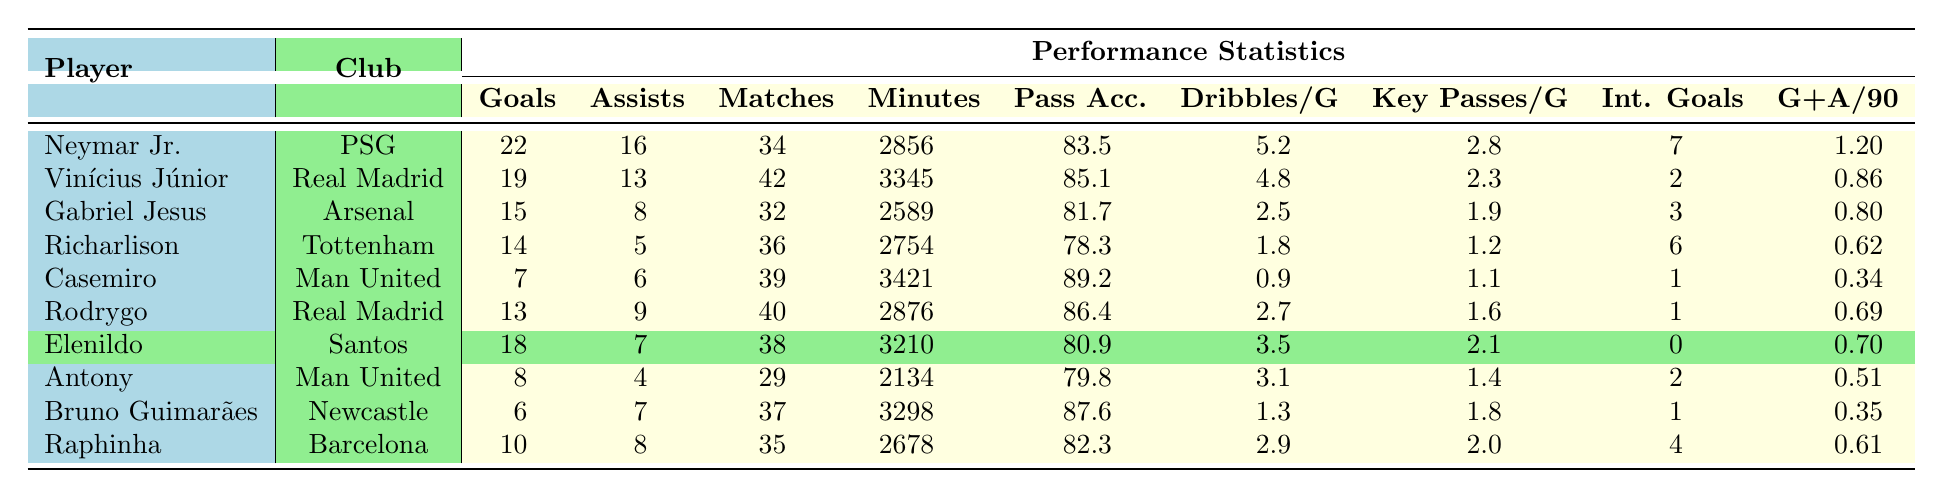What is the total number of goals scored by Neymar Jr. in 2022? The table shows that Neymar Jr. scored 22 goals in 2022.
Answer: 22 Which player had the highest number of assists in 2022? By checking the assists column, Neymar Jr. had the highest assists with 16.
Answer: Neymar Jr What is Elenildo's pass accuracy percentage? The table indicates that Elenildo had a pass accuracy of 80.9%.
Answer: 80.9% How many matches did Vinícius Júnior play in 2022? The matches played column shows that Vinícius Júnior played 42 matches.
Answer: 42 Who had the lowest goals-per-match ratio among the players listed? To find goals-per-match ratio, divide goals by matches played. Casemiro has 7 goals in 39 matches, giving a ratio of 0.18. This is lower than any other player.
Answer: Casemiro What is the total number of goals scored by all players mentioned in the table? Summing the goals: 22 + 19 + 15 + 14 + 7 + 13 + 18 + 8 + 6 + 10 = 232.
Answer: 232 Did any player score more than 20 goals in the season? By reviewing the goals column, only Neymar Jr. scored more than 20 goals (22 goals).
Answer: Yes How many players scored at least 10 goals? The players who scored at least 10 goals: Neymar Jr. (22), Vinícius Júnior (19), Elenildo (18), Gabriel Jesus (15), Richarlison (14), and Rodrygo (13). Count gives 6 players.
Answer: 6 What is the average number of international goals scored by the players in the table? Summing the international goals (7 + 2 + 3 + 6 + 1 + 1 + 0 + 2 + 1 + 4 = 27) and dividing by the number of players (10) gives an average of 27/10 = 2.7.
Answer: 2.7 Which player had the most dribbles per game? Comparing the dribbles per game, Neymar Jr. with 5.2 dribbles per game is the highest.
Answer: Neymar Jr How many assists did Richarlison contribute to his team's performance? Looking at the assists column, Richarlison had 5 assists.
Answer: 5 What percentage of his matches did Gabriel Jesus score in? Gabriel Jesus scored in 15 out of 32 matches, giving a percentage of (15/32) * 100 = 46.88%.
Answer: 46.88% Is it true that Antony played fewer matches than Elenildo? By comparing the matches played, Antony played 29 matches, and Elenildo played 38, thus Antony played fewer.
Answer: Yes What is the combined number of assists of the players from Manchester United? Casemiro contributed 6 assists, and Antony contributed 4, totaling 10 assists from Manchester United players.
Answer: 10 Which player has the highest minutes played and how many? Checking the minutes played column, Casemiro has played the most minutes with 3421.
Answer: Casemiro, 3421 minutes 